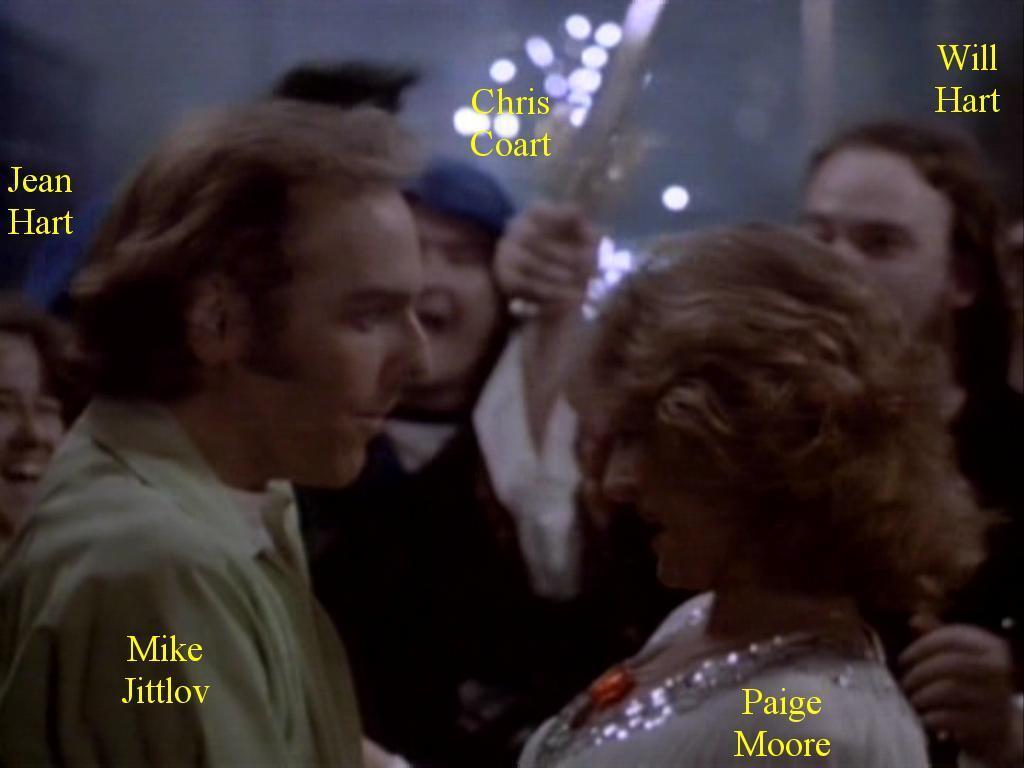Could you give a brief overview of what you see in this image? In this image, there are a few people. We can also see some text. 